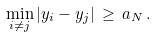Convert formula to latex. <formula><loc_0><loc_0><loc_500><loc_500>\min _ { i \not = j } | y _ { i } - y _ { j } | \, \geq \, a _ { N } \, .</formula> 